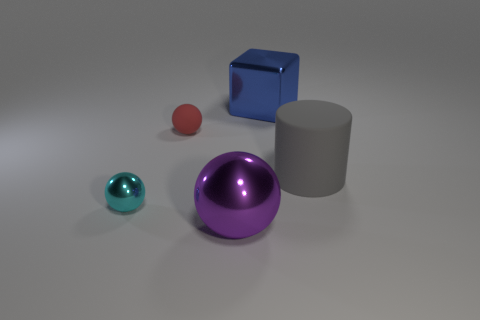There is a purple metal object that is the same shape as the cyan metal object; what is its size?
Your answer should be very brief. Large. What is the shape of the rubber object that is to the left of the shiny object behind the tiny red rubber sphere?
Give a very brief answer. Sphere. What is the size of the purple object?
Ensure brevity in your answer.  Large. There is a red rubber object; what shape is it?
Provide a succinct answer. Sphere. There is a small cyan metallic object; is it the same shape as the purple thing that is in front of the tiny red matte ball?
Offer a terse response. Yes. There is a big thing that is on the right side of the metallic block; does it have the same shape as the tiny red object?
Offer a terse response. No. How many metal objects are in front of the large matte cylinder and behind the purple thing?
Your response must be concise. 1. What number of other objects are the same size as the metallic cube?
Your answer should be very brief. 2. Are there an equal number of small matte objects left of the cyan ball and green shiny spheres?
Your answer should be compact. Yes. Do the large metallic thing that is in front of the cyan sphere and the tiny ball in front of the gray rubber cylinder have the same color?
Offer a terse response. No. 